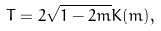<formula> <loc_0><loc_0><loc_500><loc_500>T = 2 \sqrt { 1 - 2 m } K ( m ) ,</formula> 